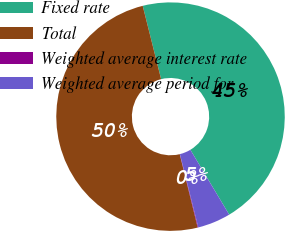<chart> <loc_0><loc_0><loc_500><loc_500><pie_chart><fcel>Fixed rate<fcel>Total<fcel>Weighted average interest rate<fcel>Weighted average period for<nl><fcel>45.33%<fcel>49.91%<fcel>0.09%<fcel>4.67%<nl></chart> 